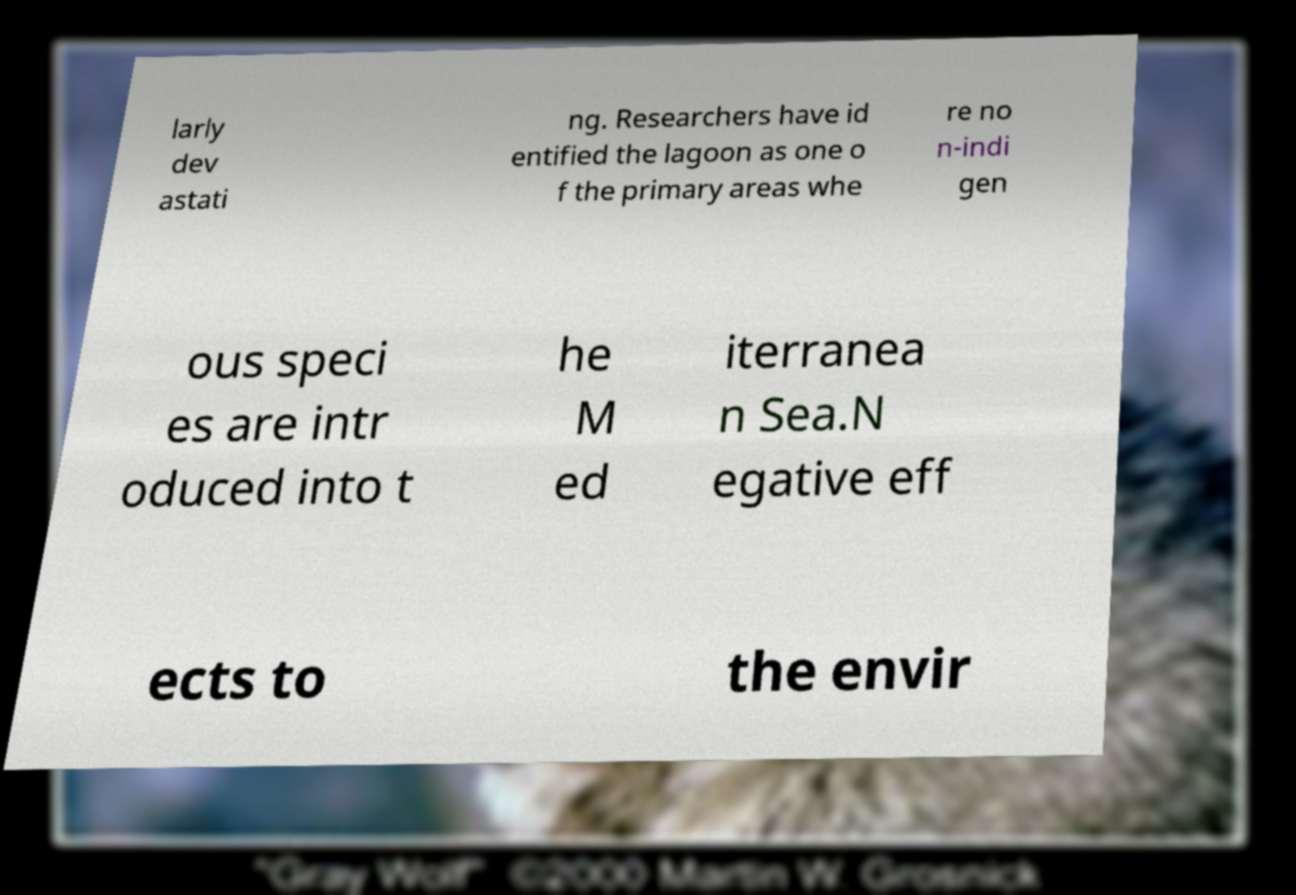Can you accurately transcribe the text from the provided image for me? larly dev astati ng. Researchers have id entified the lagoon as one o f the primary areas whe re no n-indi gen ous speci es are intr oduced into t he M ed iterranea n Sea.N egative eff ects to the envir 